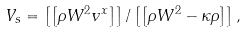<formula> <loc_0><loc_0><loc_500><loc_500>V _ { s } = \left [ \left [ \rho W ^ { 2 } v ^ { x } \right ] \right ] / \left [ \left [ \rho W ^ { 2 } - \kappa \rho \right ] \right ] ,</formula> 